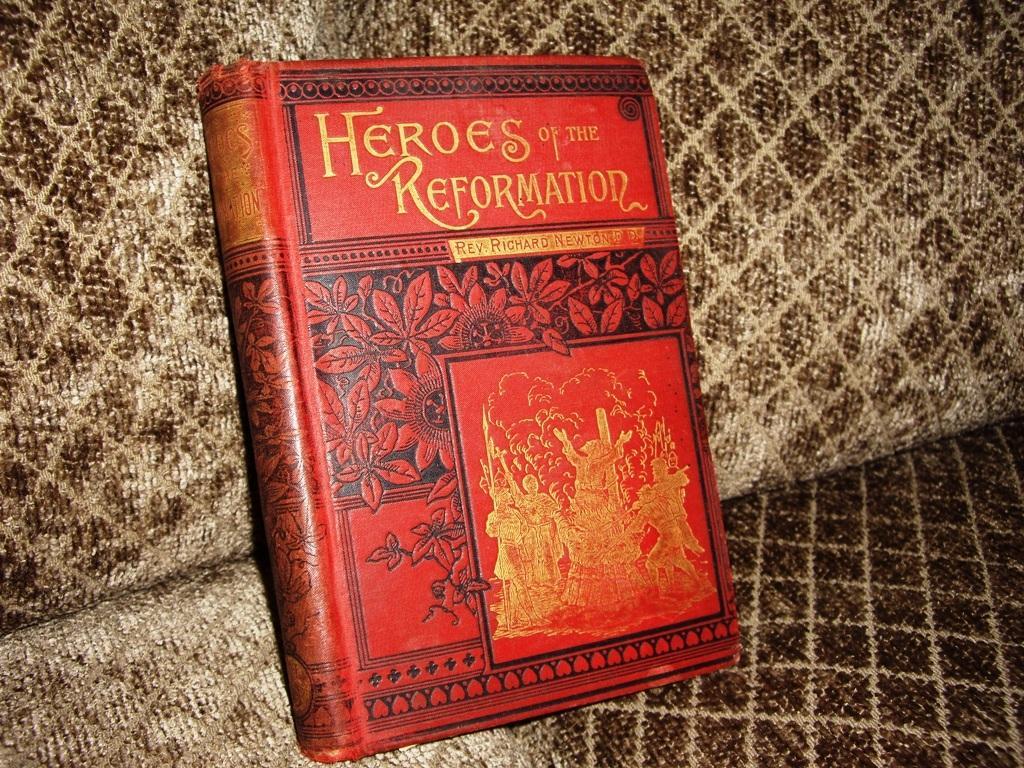Could you give a brief overview of what you see in this image? This image consists of a book on the sofa. This picture is taken in a house. 